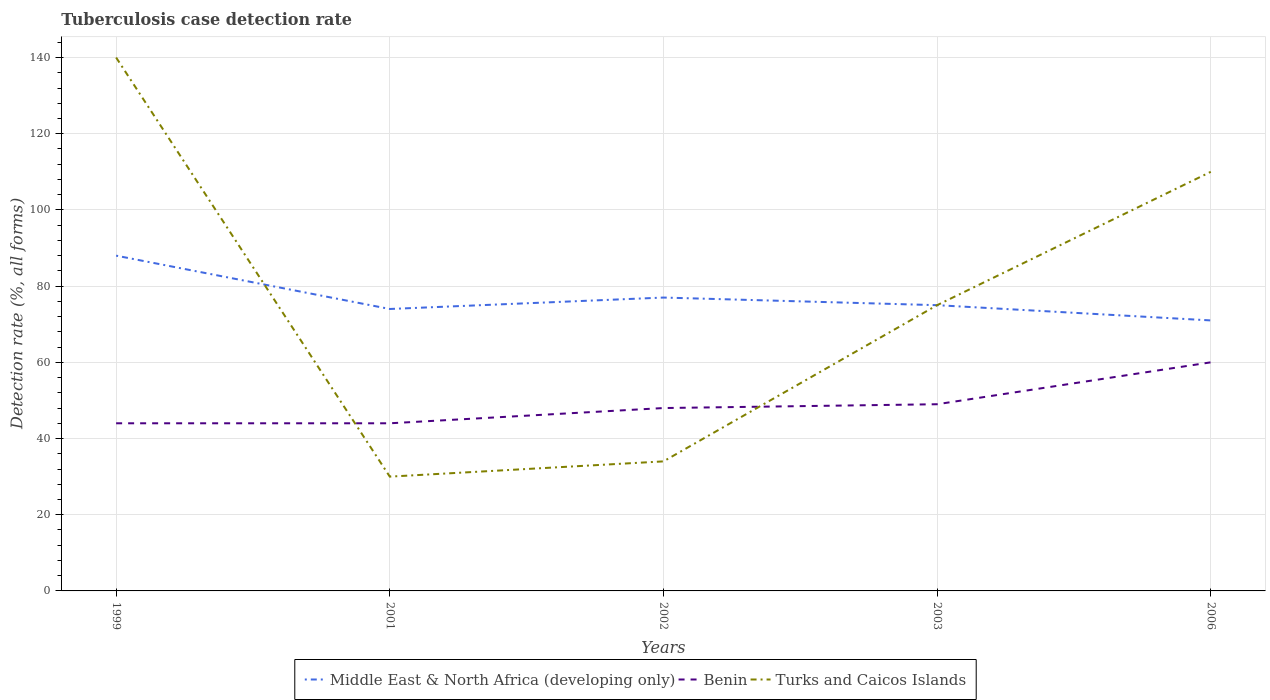How many different coloured lines are there?
Your response must be concise. 3. Across all years, what is the maximum tuberculosis case detection rate in in Turks and Caicos Islands?
Provide a short and direct response. 30. What is the total tuberculosis case detection rate in in Benin in the graph?
Offer a very short reply. -5. What is the difference between the highest and the second highest tuberculosis case detection rate in in Benin?
Your answer should be compact. 16. What is the difference between the highest and the lowest tuberculosis case detection rate in in Turks and Caicos Islands?
Give a very brief answer. 2. Are the values on the major ticks of Y-axis written in scientific E-notation?
Offer a terse response. No. Does the graph contain any zero values?
Your answer should be compact. No. What is the title of the graph?
Keep it short and to the point. Tuberculosis case detection rate. What is the label or title of the X-axis?
Give a very brief answer. Years. What is the label or title of the Y-axis?
Keep it short and to the point. Detection rate (%, all forms). What is the Detection rate (%, all forms) of Middle East & North Africa (developing only) in 1999?
Offer a very short reply. 88. What is the Detection rate (%, all forms) of Benin in 1999?
Your answer should be compact. 44. What is the Detection rate (%, all forms) in Turks and Caicos Islands in 1999?
Offer a very short reply. 140. What is the Detection rate (%, all forms) of Benin in 2001?
Offer a terse response. 44. What is the Detection rate (%, all forms) in Turks and Caicos Islands in 2002?
Make the answer very short. 34. What is the Detection rate (%, all forms) in Middle East & North Africa (developing only) in 2003?
Your response must be concise. 75. What is the Detection rate (%, all forms) of Turks and Caicos Islands in 2003?
Offer a terse response. 75. What is the Detection rate (%, all forms) of Turks and Caicos Islands in 2006?
Offer a terse response. 110. Across all years, what is the maximum Detection rate (%, all forms) of Middle East & North Africa (developing only)?
Provide a short and direct response. 88. Across all years, what is the maximum Detection rate (%, all forms) of Turks and Caicos Islands?
Ensure brevity in your answer.  140. Across all years, what is the minimum Detection rate (%, all forms) in Middle East & North Africa (developing only)?
Make the answer very short. 71. Across all years, what is the minimum Detection rate (%, all forms) in Benin?
Keep it short and to the point. 44. What is the total Detection rate (%, all forms) in Middle East & North Africa (developing only) in the graph?
Your answer should be compact. 385. What is the total Detection rate (%, all forms) of Benin in the graph?
Your answer should be very brief. 245. What is the total Detection rate (%, all forms) of Turks and Caicos Islands in the graph?
Your response must be concise. 389. What is the difference between the Detection rate (%, all forms) in Benin in 1999 and that in 2001?
Ensure brevity in your answer.  0. What is the difference between the Detection rate (%, all forms) of Turks and Caicos Islands in 1999 and that in 2001?
Make the answer very short. 110. What is the difference between the Detection rate (%, all forms) of Middle East & North Africa (developing only) in 1999 and that in 2002?
Offer a terse response. 11. What is the difference between the Detection rate (%, all forms) of Turks and Caicos Islands in 1999 and that in 2002?
Give a very brief answer. 106. What is the difference between the Detection rate (%, all forms) of Benin in 1999 and that in 2003?
Provide a succinct answer. -5. What is the difference between the Detection rate (%, all forms) in Turks and Caicos Islands in 1999 and that in 2003?
Offer a very short reply. 65. What is the difference between the Detection rate (%, all forms) in Benin in 1999 and that in 2006?
Make the answer very short. -16. What is the difference between the Detection rate (%, all forms) of Benin in 2001 and that in 2002?
Your answer should be compact. -4. What is the difference between the Detection rate (%, all forms) in Turks and Caicos Islands in 2001 and that in 2003?
Provide a short and direct response. -45. What is the difference between the Detection rate (%, all forms) of Turks and Caicos Islands in 2001 and that in 2006?
Provide a short and direct response. -80. What is the difference between the Detection rate (%, all forms) of Benin in 2002 and that in 2003?
Offer a terse response. -1. What is the difference between the Detection rate (%, all forms) of Turks and Caicos Islands in 2002 and that in 2003?
Make the answer very short. -41. What is the difference between the Detection rate (%, all forms) of Turks and Caicos Islands in 2002 and that in 2006?
Provide a short and direct response. -76. What is the difference between the Detection rate (%, all forms) of Middle East & North Africa (developing only) in 2003 and that in 2006?
Offer a very short reply. 4. What is the difference between the Detection rate (%, all forms) in Turks and Caicos Islands in 2003 and that in 2006?
Provide a succinct answer. -35. What is the difference between the Detection rate (%, all forms) of Middle East & North Africa (developing only) in 1999 and the Detection rate (%, all forms) of Benin in 2001?
Offer a terse response. 44. What is the difference between the Detection rate (%, all forms) in Middle East & North Africa (developing only) in 1999 and the Detection rate (%, all forms) in Turks and Caicos Islands in 2001?
Provide a succinct answer. 58. What is the difference between the Detection rate (%, all forms) in Middle East & North Africa (developing only) in 1999 and the Detection rate (%, all forms) in Benin in 2003?
Offer a terse response. 39. What is the difference between the Detection rate (%, all forms) of Benin in 1999 and the Detection rate (%, all forms) of Turks and Caicos Islands in 2003?
Provide a succinct answer. -31. What is the difference between the Detection rate (%, all forms) in Benin in 1999 and the Detection rate (%, all forms) in Turks and Caicos Islands in 2006?
Give a very brief answer. -66. What is the difference between the Detection rate (%, all forms) of Middle East & North Africa (developing only) in 2001 and the Detection rate (%, all forms) of Benin in 2002?
Your answer should be very brief. 26. What is the difference between the Detection rate (%, all forms) of Middle East & North Africa (developing only) in 2001 and the Detection rate (%, all forms) of Turks and Caicos Islands in 2002?
Your response must be concise. 40. What is the difference between the Detection rate (%, all forms) in Benin in 2001 and the Detection rate (%, all forms) in Turks and Caicos Islands in 2002?
Your answer should be very brief. 10. What is the difference between the Detection rate (%, all forms) in Middle East & North Africa (developing only) in 2001 and the Detection rate (%, all forms) in Benin in 2003?
Make the answer very short. 25. What is the difference between the Detection rate (%, all forms) in Benin in 2001 and the Detection rate (%, all forms) in Turks and Caicos Islands in 2003?
Offer a very short reply. -31. What is the difference between the Detection rate (%, all forms) of Middle East & North Africa (developing only) in 2001 and the Detection rate (%, all forms) of Turks and Caicos Islands in 2006?
Offer a terse response. -36. What is the difference between the Detection rate (%, all forms) of Benin in 2001 and the Detection rate (%, all forms) of Turks and Caicos Islands in 2006?
Your response must be concise. -66. What is the difference between the Detection rate (%, all forms) in Middle East & North Africa (developing only) in 2002 and the Detection rate (%, all forms) in Benin in 2003?
Provide a succinct answer. 28. What is the difference between the Detection rate (%, all forms) in Middle East & North Africa (developing only) in 2002 and the Detection rate (%, all forms) in Benin in 2006?
Ensure brevity in your answer.  17. What is the difference between the Detection rate (%, all forms) in Middle East & North Africa (developing only) in 2002 and the Detection rate (%, all forms) in Turks and Caicos Islands in 2006?
Keep it short and to the point. -33. What is the difference between the Detection rate (%, all forms) in Benin in 2002 and the Detection rate (%, all forms) in Turks and Caicos Islands in 2006?
Keep it short and to the point. -62. What is the difference between the Detection rate (%, all forms) in Middle East & North Africa (developing only) in 2003 and the Detection rate (%, all forms) in Turks and Caicos Islands in 2006?
Keep it short and to the point. -35. What is the difference between the Detection rate (%, all forms) in Benin in 2003 and the Detection rate (%, all forms) in Turks and Caicos Islands in 2006?
Provide a succinct answer. -61. What is the average Detection rate (%, all forms) of Turks and Caicos Islands per year?
Your answer should be very brief. 77.8. In the year 1999, what is the difference between the Detection rate (%, all forms) in Middle East & North Africa (developing only) and Detection rate (%, all forms) in Turks and Caicos Islands?
Your response must be concise. -52. In the year 1999, what is the difference between the Detection rate (%, all forms) in Benin and Detection rate (%, all forms) in Turks and Caicos Islands?
Give a very brief answer. -96. In the year 2002, what is the difference between the Detection rate (%, all forms) in Middle East & North Africa (developing only) and Detection rate (%, all forms) in Benin?
Your answer should be compact. 29. In the year 2002, what is the difference between the Detection rate (%, all forms) in Middle East & North Africa (developing only) and Detection rate (%, all forms) in Turks and Caicos Islands?
Provide a succinct answer. 43. In the year 2002, what is the difference between the Detection rate (%, all forms) in Benin and Detection rate (%, all forms) in Turks and Caicos Islands?
Your answer should be very brief. 14. In the year 2003, what is the difference between the Detection rate (%, all forms) in Middle East & North Africa (developing only) and Detection rate (%, all forms) in Turks and Caicos Islands?
Give a very brief answer. 0. In the year 2003, what is the difference between the Detection rate (%, all forms) in Benin and Detection rate (%, all forms) in Turks and Caicos Islands?
Offer a very short reply. -26. In the year 2006, what is the difference between the Detection rate (%, all forms) of Middle East & North Africa (developing only) and Detection rate (%, all forms) of Turks and Caicos Islands?
Offer a very short reply. -39. In the year 2006, what is the difference between the Detection rate (%, all forms) in Benin and Detection rate (%, all forms) in Turks and Caicos Islands?
Provide a short and direct response. -50. What is the ratio of the Detection rate (%, all forms) in Middle East & North Africa (developing only) in 1999 to that in 2001?
Make the answer very short. 1.19. What is the ratio of the Detection rate (%, all forms) in Turks and Caicos Islands in 1999 to that in 2001?
Offer a very short reply. 4.67. What is the ratio of the Detection rate (%, all forms) of Middle East & North Africa (developing only) in 1999 to that in 2002?
Give a very brief answer. 1.14. What is the ratio of the Detection rate (%, all forms) in Turks and Caicos Islands in 1999 to that in 2002?
Keep it short and to the point. 4.12. What is the ratio of the Detection rate (%, all forms) of Middle East & North Africa (developing only) in 1999 to that in 2003?
Keep it short and to the point. 1.17. What is the ratio of the Detection rate (%, all forms) in Benin in 1999 to that in 2003?
Offer a very short reply. 0.9. What is the ratio of the Detection rate (%, all forms) of Turks and Caicos Islands in 1999 to that in 2003?
Keep it short and to the point. 1.87. What is the ratio of the Detection rate (%, all forms) of Middle East & North Africa (developing only) in 1999 to that in 2006?
Ensure brevity in your answer.  1.24. What is the ratio of the Detection rate (%, all forms) of Benin in 1999 to that in 2006?
Provide a succinct answer. 0.73. What is the ratio of the Detection rate (%, all forms) of Turks and Caicos Islands in 1999 to that in 2006?
Keep it short and to the point. 1.27. What is the ratio of the Detection rate (%, all forms) in Benin in 2001 to that in 2002?
Give a very brief answer. 0.92. What is the ratio of the Detection rate (%, all forms) in Turks and Caicos Islands in 2001 to that in 2002?
Your response must be concise. 0.88. What is the ratio of the Detection rate (%, all forms) in Middle East & North Africa (developing only) in 2001 to that in 2003?
Offer a terse response. 0.99. What is the ratio of the Detection rate (%, all forms) in Benin in 2001 to that in 2003?
Provide a succinct answer. 0.9. What is the ratio of the Detection rate (%, all forms) of Middle East & North Africa (developing only) in 2001 to that in 2006?
Your answer should be compact. 1.04. What is the ratio of the Detection rate (%, all forms) in Benin in 2001 to that in 2006?
Your answer should be very brief. 0.73. What is the ratio of the Detection rate (%, all forms) in Turks and Caicos Islands in 2001 to that in 2006?
Provide a succinct answer. 0.27. What is the ratio of the Detection rate (%, all forms) of Middle East & North Africa (developing only) in 2002 to that in 2003?
Ensure brevity in your answer.  1.03. What is the ratio of the Detection rate (%, all forms) in Benin in 2002 to that in 2003?
Provide a short and direct response. 0.98. What is the ratio of the Detection rate (%, all forms) in Turks and Caicos Islands in 2002 to that in 2003?
Ensure brevity in your answer.  0.45. What is the ratio of the Detection rate (%, all forms) of Middle East & North Africa (developing only) in 2002 to that in 2006?
Offer a very short reply. 1.08. What is the ratio of the Detection rate (%, all forms) in Turks and Caicos Islands in 2002 to that in 2006?
Your answer should be compact. 0.31. What is the ratio of the Detection rate (%, all forms) of Middle East & North Africa (developing only) in 2003 to that in 2006?
Ensure brevity in your answer.  1.06. What is the ratio of the Detection rate (%, all forms) of Benin in 2003 to that in 2006?
Your answer should be compact. 0.82. What is the ratio of the Detection rate (%, all forms) of Turks and Caicos Islands in 2003 to that in 2006?
Keep it short and to the point. 0.68. What is the difference between the highest and the lowest Detection rate (%, all forms) of Middle East & North Africa (developing only)?
Give a very brief answer. 17. What is the difference between the highest and the lowest Detection rate (%, all forms) of Benin?
Provide a succinct answer. 16. What is the difference between the highest and the lowest Detection rate (%, all forms) in Turks and Caicos Islands?
Offer a very short reply. 110. 